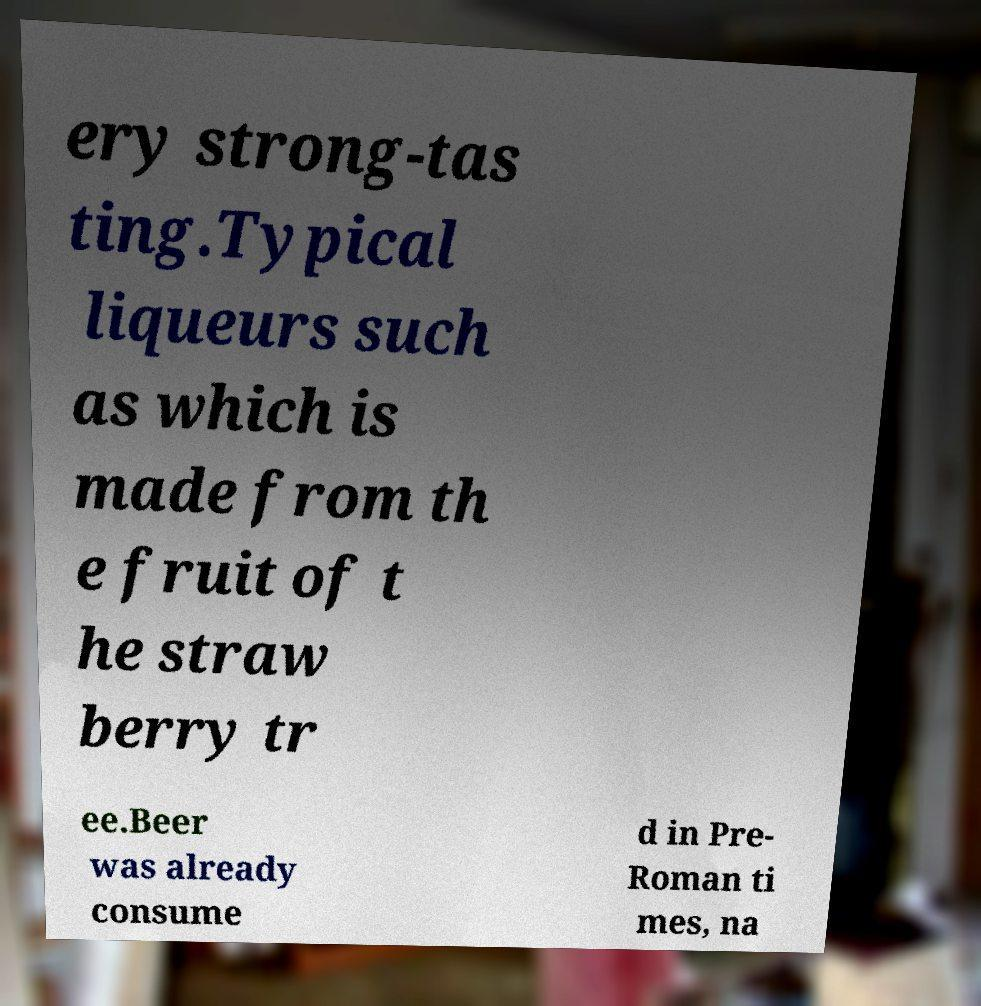Could you extract and type out the text from this image? ery strong-tas ting.Typical liqueurs such as which is made from th e fruit of t he straw berry tr ee.Beer was already consume d in Pre- Roman ti mes, na 